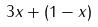<formula> <loc_0><loc_0><loc_500><loc_500>3 x + ( 1 - x )</formula> 